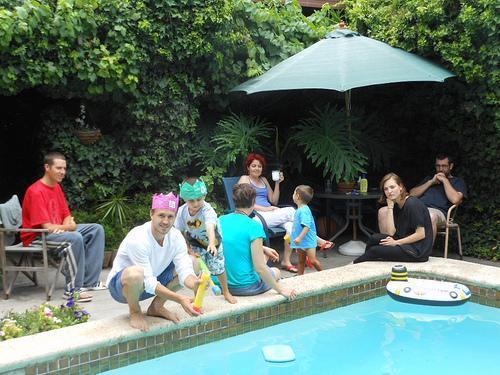How many umbrellas are there?
Give a very brief answer. 1. How many people are wearing a crown?
Give a very brief answer. 2. 